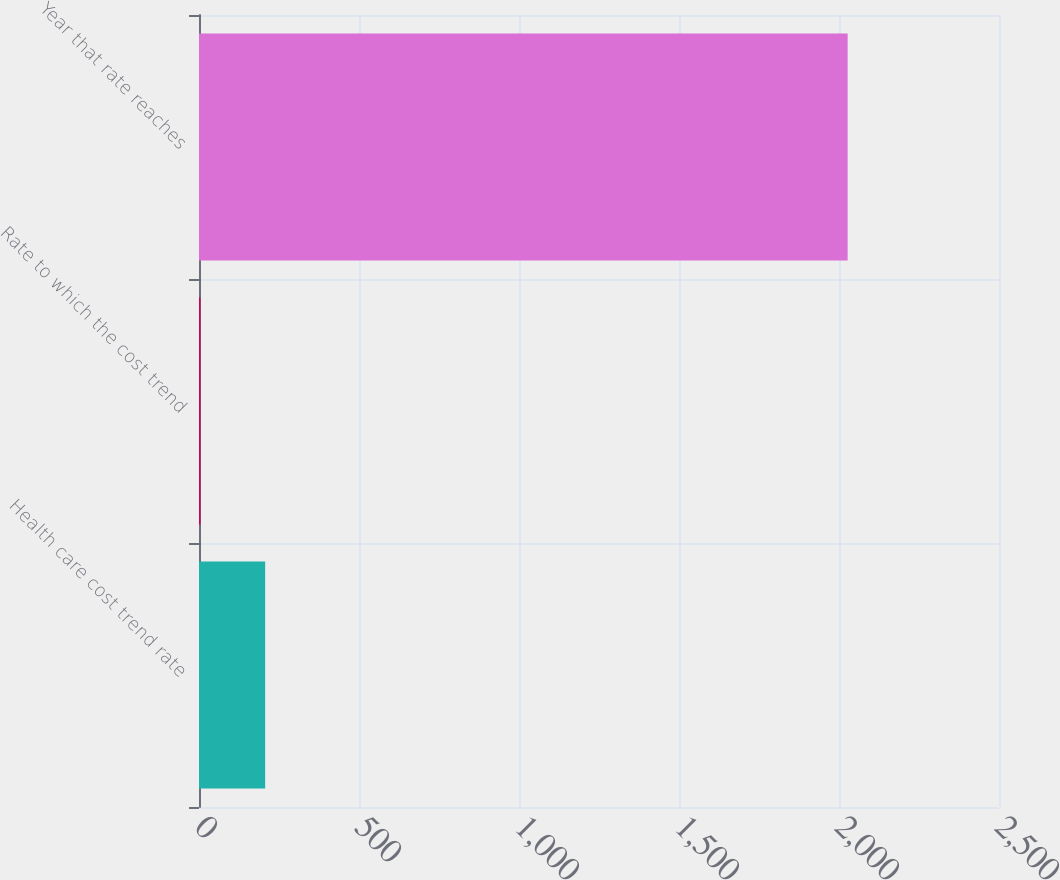<chart> <loc_0><loc_0><loc_500><loc_500><bar_chart><fcel>Health care cost trend rate<fcel>Rate to which the cost trend<fcel>Year that rate reaches<nl><fcel>206.75<fcel>4.5<fcel>2027<nl></chart> 